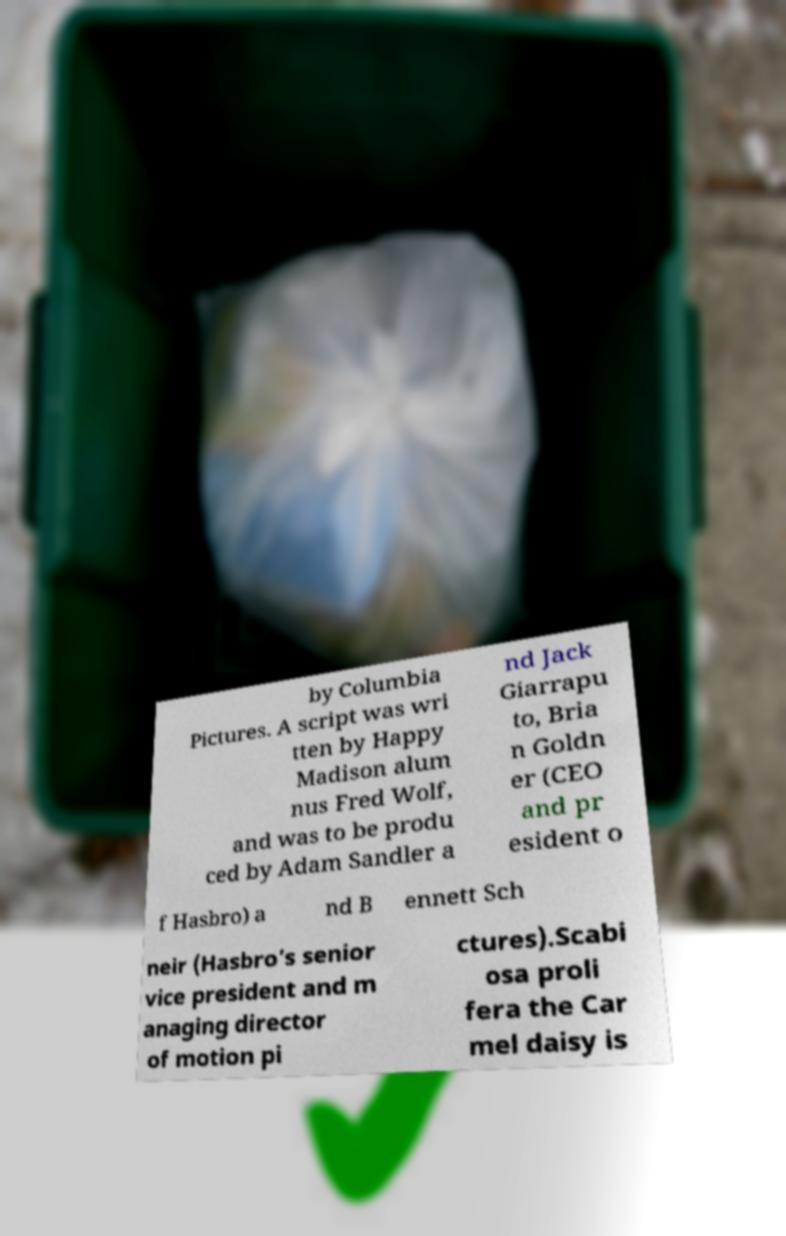I need the written content from this picture converted into text. Can you do that? by Columbia Pictures. A script was wri tten by Happy Madison alum nus Fred Wolf, and was to be produ ced by Adam Sandler a nd Jack Giarrapu to, Bria n Goldn er (CEO and pr esident o f Hasbro) a nd B ennett Sch neir (Hasbro’s senior vice president and m anaging director of motion pi ctures).Scabi osa proli fera the Car mel daisy is 